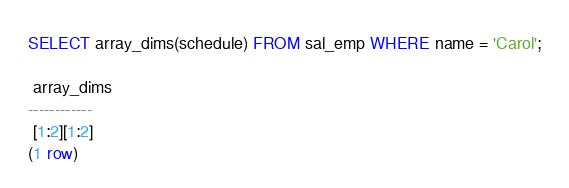<code> <loc_0><loc_0><loc_500><loc_500><_SQL_>SELECT array_dims(schedule) FROM sal_emp WHERE name = 'Carol';

 array_dims
------------
 [1:2][1:2]
(1 row)
</code> 